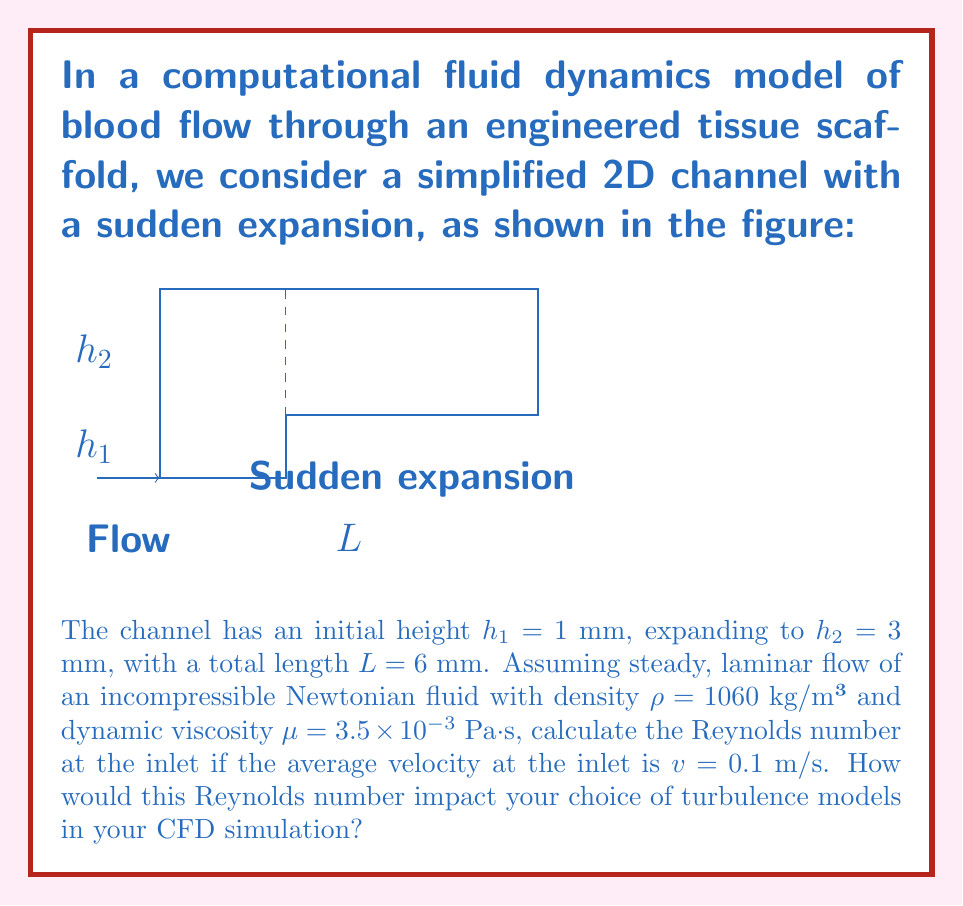Can you solve this math problem? To solve this problem, we'll follow these steps:

1) The Reynolds number (Re) is a dimensionless quantity that helps predict flow patterns in different fluid flow situations. It's defined as:

   $$Re = \frac{\rho v D_h}{\mu}$$

   where $\rho$ is the fluid density, $v$ is the characteristic velocity, $D_h$ is the hydraulic diameter, and $\mu$ is the dynamic viscosity.

2) For a rectangular channel, the hydraulic diameter is given by:

   $$D_h = \frac{4A}{P} = \frac{4wh}{2(w+h)}$$

   where $A$ is the cross-sectional area and $P$ is the wetted perimeter.

3) For a very wide channel (where width $w$ >> height $h$), this simplifies to:

   $$D_h \approx 2h$$

4) In our case, at the inlet, $h_1 = 1$ mm = $1 \times 10^{-3}$ m, so:

   $$D_h = 2 \times (1 \times 10^{-3}) = 2 \times 10^{-3} \text{ m}$$

5) Now we can calculate the Reynolds number:

   $$Re = \frac{(1060)(0.1)(2 \times 10^{-3})}{3.5 \times 10^{-3}} = 60.57$$

6) Regarding the impact on turbulence models:
   - This Re is well below 2300, which is typically considered the upper limit for laminar flow in pipes.
   - For Re < 2300, flow is generally considered laminar, and no turbulence model is needed.
   - In CFD simulations, you would likely use a laminar flow model for this Reynolds number.
   - However, the sudden expansion might introduce local turbulence or recirculation, which could require more complex modeling approaches.
Answer: Re = 60.57; laminar flow model appropriate, but consider local effects at expansion. 